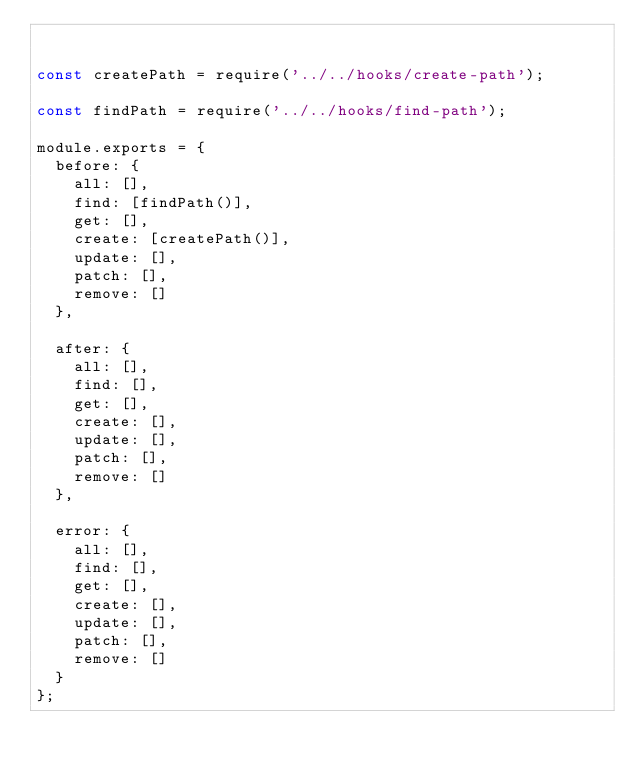Convert code to text. <code><loc_0><loc_0><loc_500><loc_500><_JavaScript_>

const createPath = require('../../hooks/create-path');

const findPath = require('../../hooks/find-path');

module.exports = {
  before: {
    all: [],
    find: [findPath()],
    get: [],
    create: [createPath()],
    update: [],
    patch: [],
    remove: []
  },

  after: {
    all: [],
    find: [],
    get: [],
    create: [],
    update: [],
    patch: [],
    remove: []
  },

  error: {
    all: [],
    find: [],
    get: [],
    create: [],
    update: [],
    patch: [],
    remove: []
  }
};
</code> 